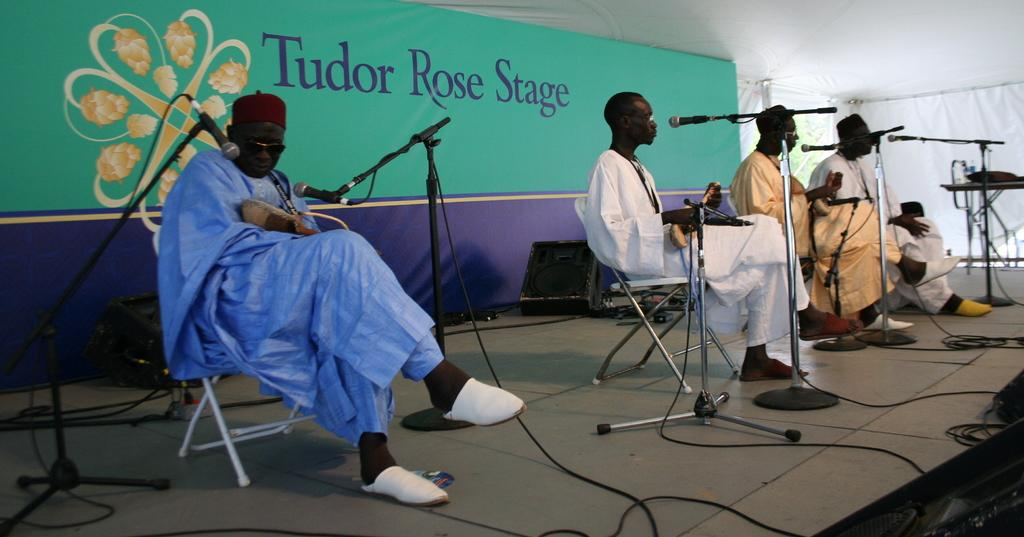What are the people in the image doing? The people in the center of the image are sitting. What objects are placed in front of the people? Microphones are placed before the people. What can be seen at the bottom of the image? There are wires at the bottom of the image. What is visible in the background of the image? There is a board and speakers in the background of the image. How many sisters are sitting next to each other in the image? There is no mention of sisters in the image, and no information is provided about their relationships. 